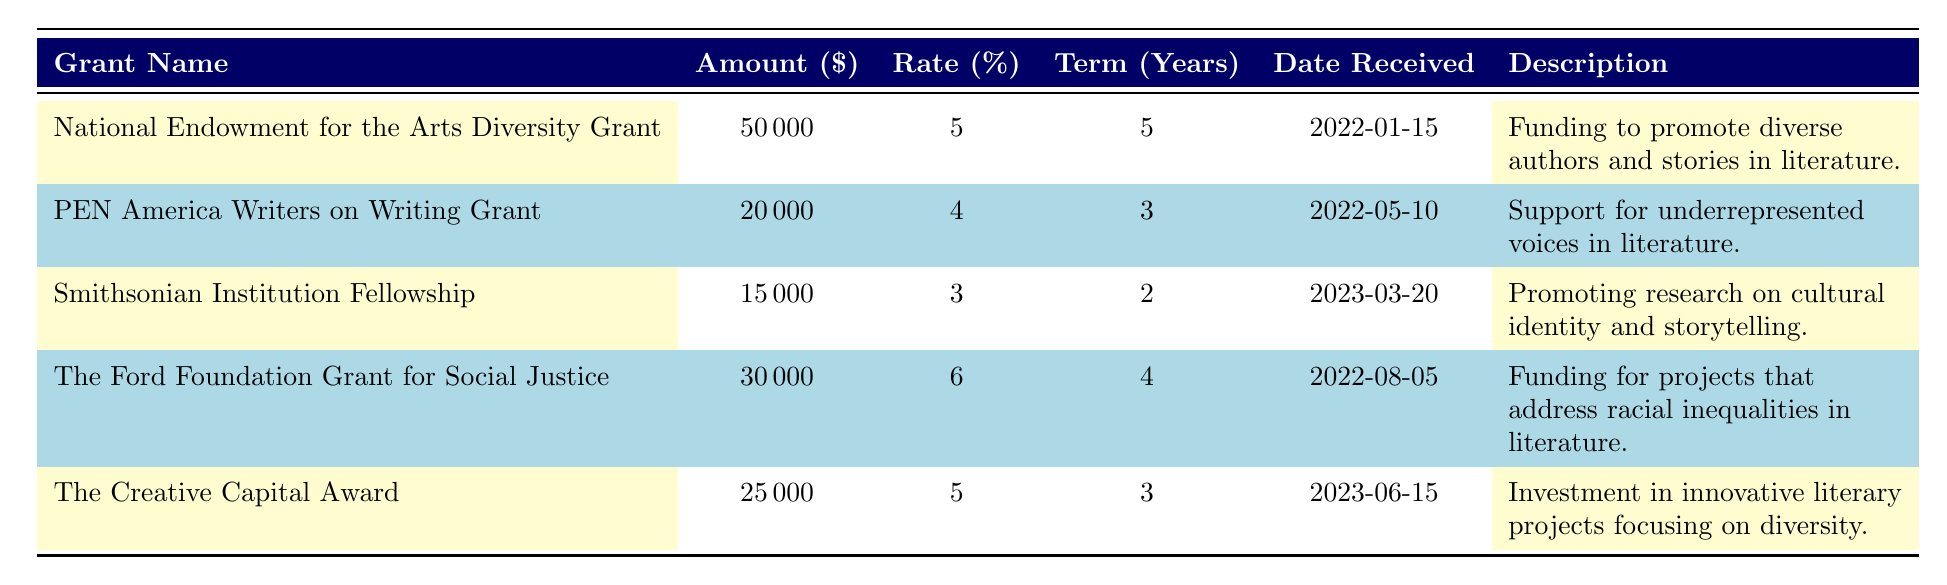What is the total amount received from all grants? To find the total amount received, we need to add up all the amounts from each grant: 50000 + 20000 + 15000 + 30000 + 25000 = 140000.
Answer: 140000 Which grant has the highest interest rate? The table shows the interest rates for each grant. The National Endowment for the Arts Diversity Grant has an interest rate of 5%, PEN America Writers on Writing Grant has 4%, Smithsonian Institution Fellowship has 3%, The Ford Foundation Grant for Social Justice has 6%, and The Creative Capital Award has 5%. The highest rate is therefore 6% from The Ford Foundation Grant for Social Justice.
Answer: The Ford Foundation Grant for Social Justice Is the total amount received for grants focused on diversity greater than 100,000? The total amount received for the four diversity-focused grants is 50000 + 20000 + 30000 + 25000 = 125000. This amount is greater than 100,000.
Answer: Yes How many grants were received in 2022? By looking at the dates received, grants were received on January 15, May 10, and August 5 of 2022. Therefore, three grants were received in that year.
Answer: 3 What is the average term duration of the grants? To find the average term, sum the term years: 5 + 3 + 2 + 4 + 3 = 17. There are 5 grants, so the average is 17/5 = 3.4 years.
Answer: 3.4 Which grant was received most recently and when? The most recent date received is June 15, 2023, corresponding to The Creative Capital Award.
Answer: The Creative Capital Award, June 15, 2023 Is the amount of the Smithsonian Institution Fellowship less than the average amount of all grants? The average amount is 140000 / 5 = 28000. The amount for the Smithsonian Institution Fellowship is 15000, which is less than 28000.
Answer: Yes What is the difference in total amounts between the highest and lowest grants? The highest grant amount is 50000 (National Endowment for the Arts Diversity Grant) and the lowest is 15000 (Smithsonian Institution Fellowship). The difference is 50000 - 15000 = 35000.
Answer: 35000 